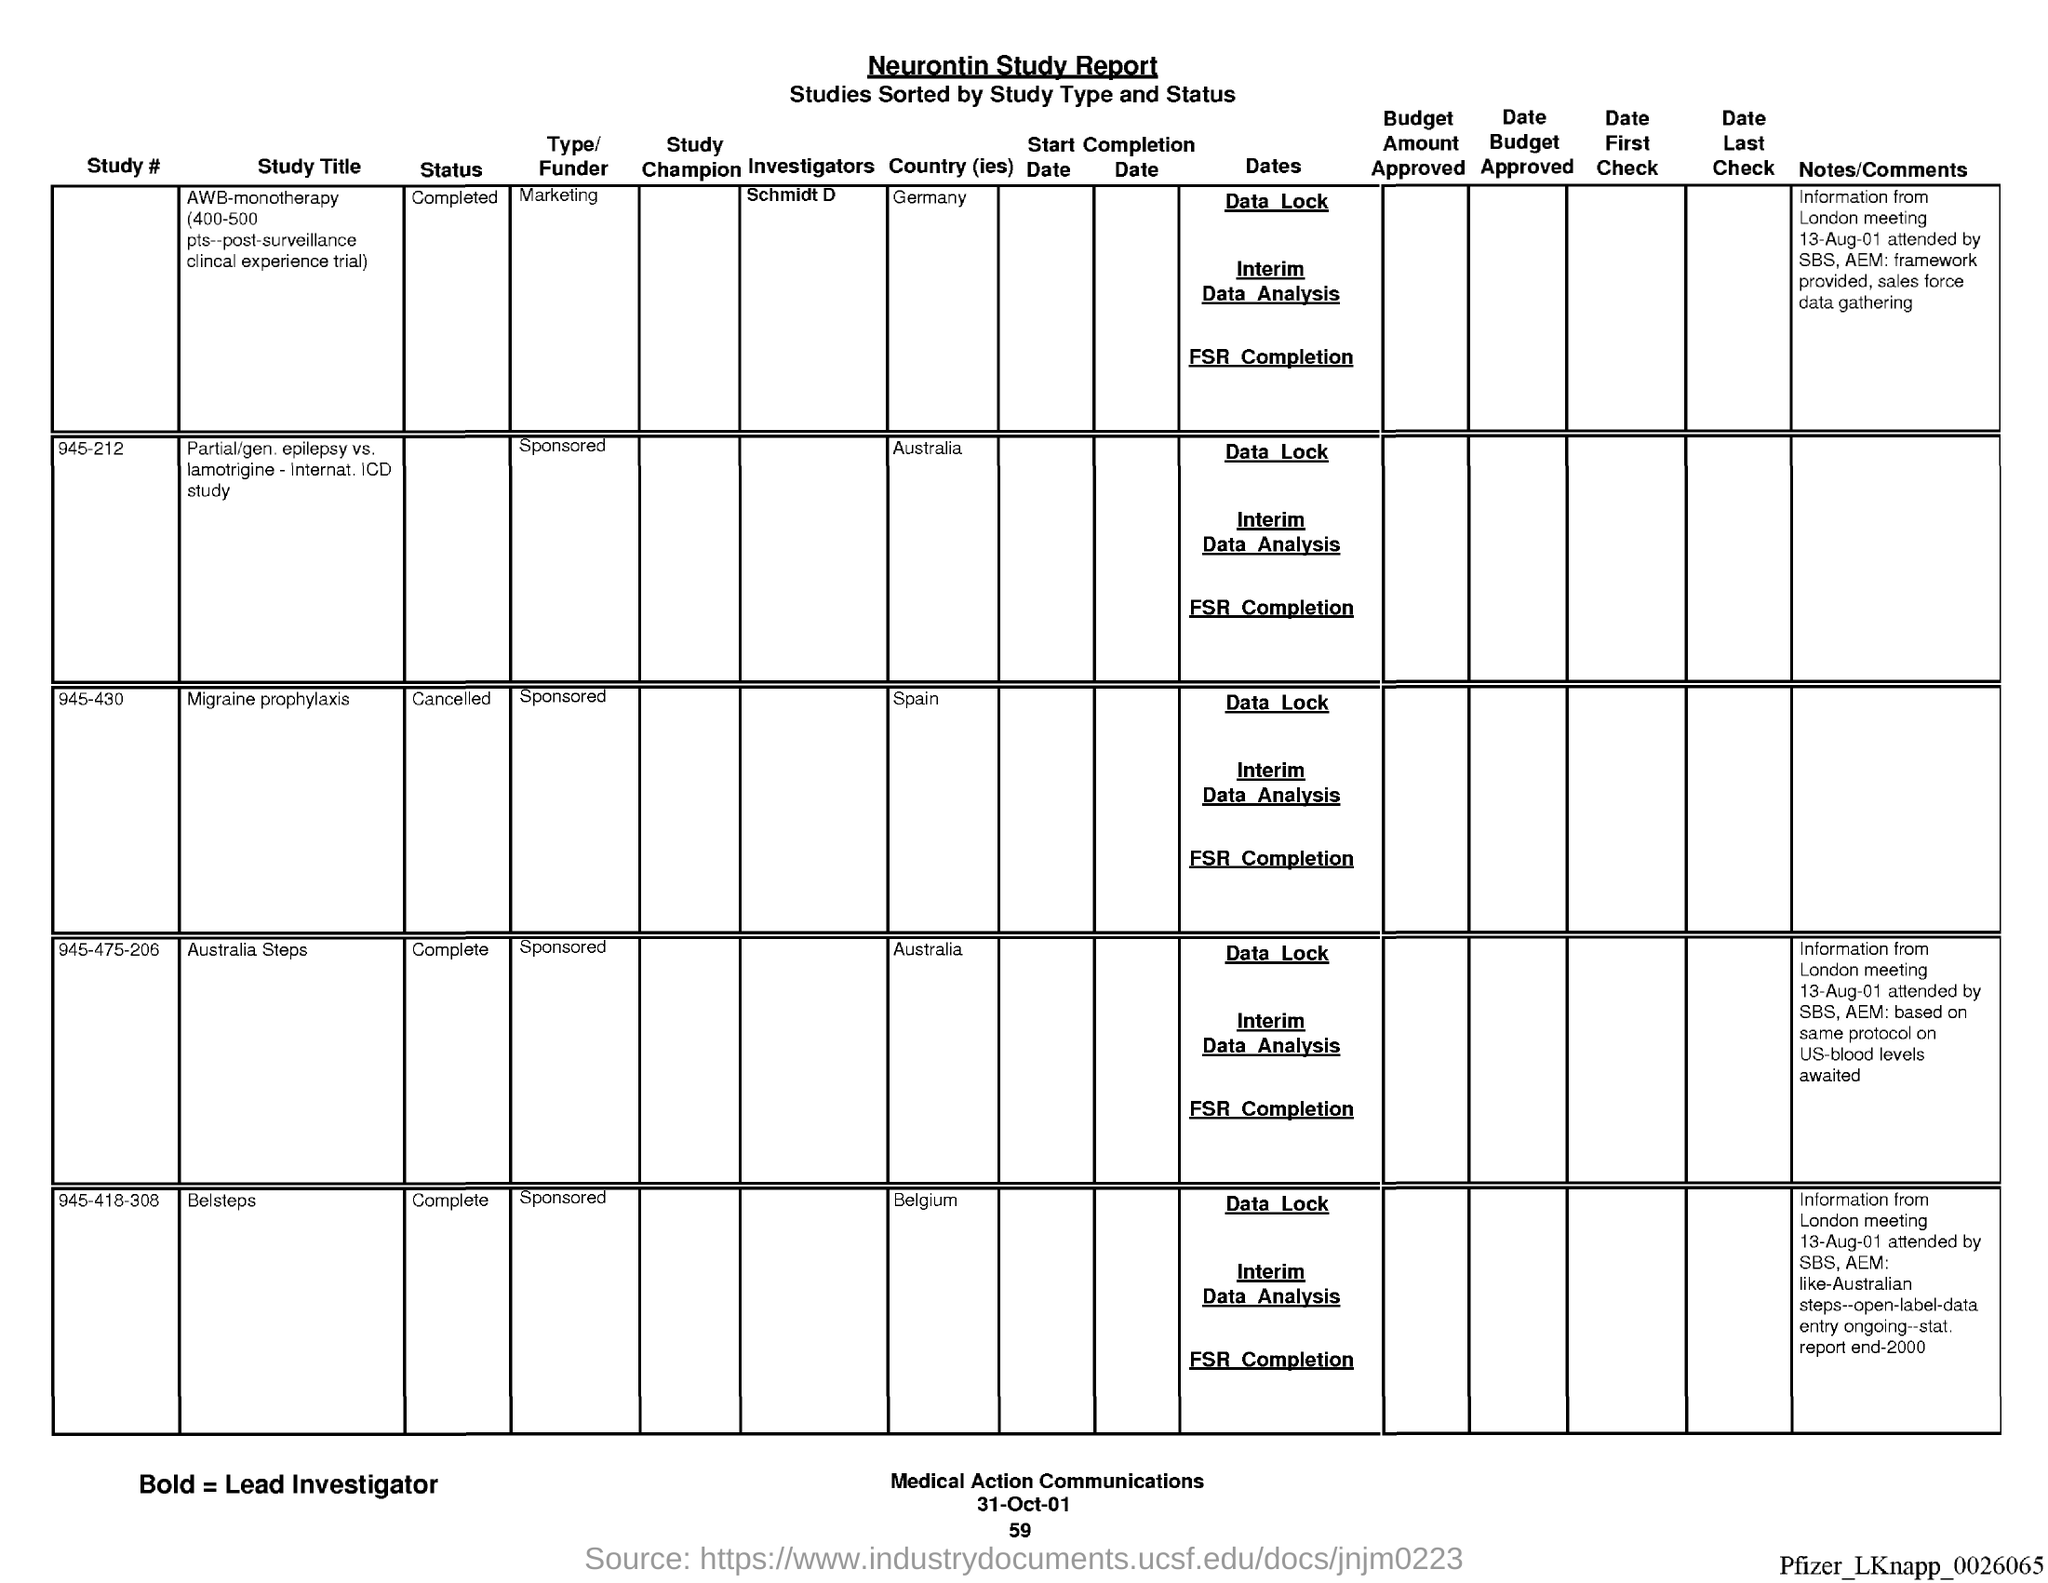Indicate a few pertinent items in this graphic. The name of the report is the Neurontin study report. The date at the bottom of the page is "31-oct-01. The page number below the date is 59. 